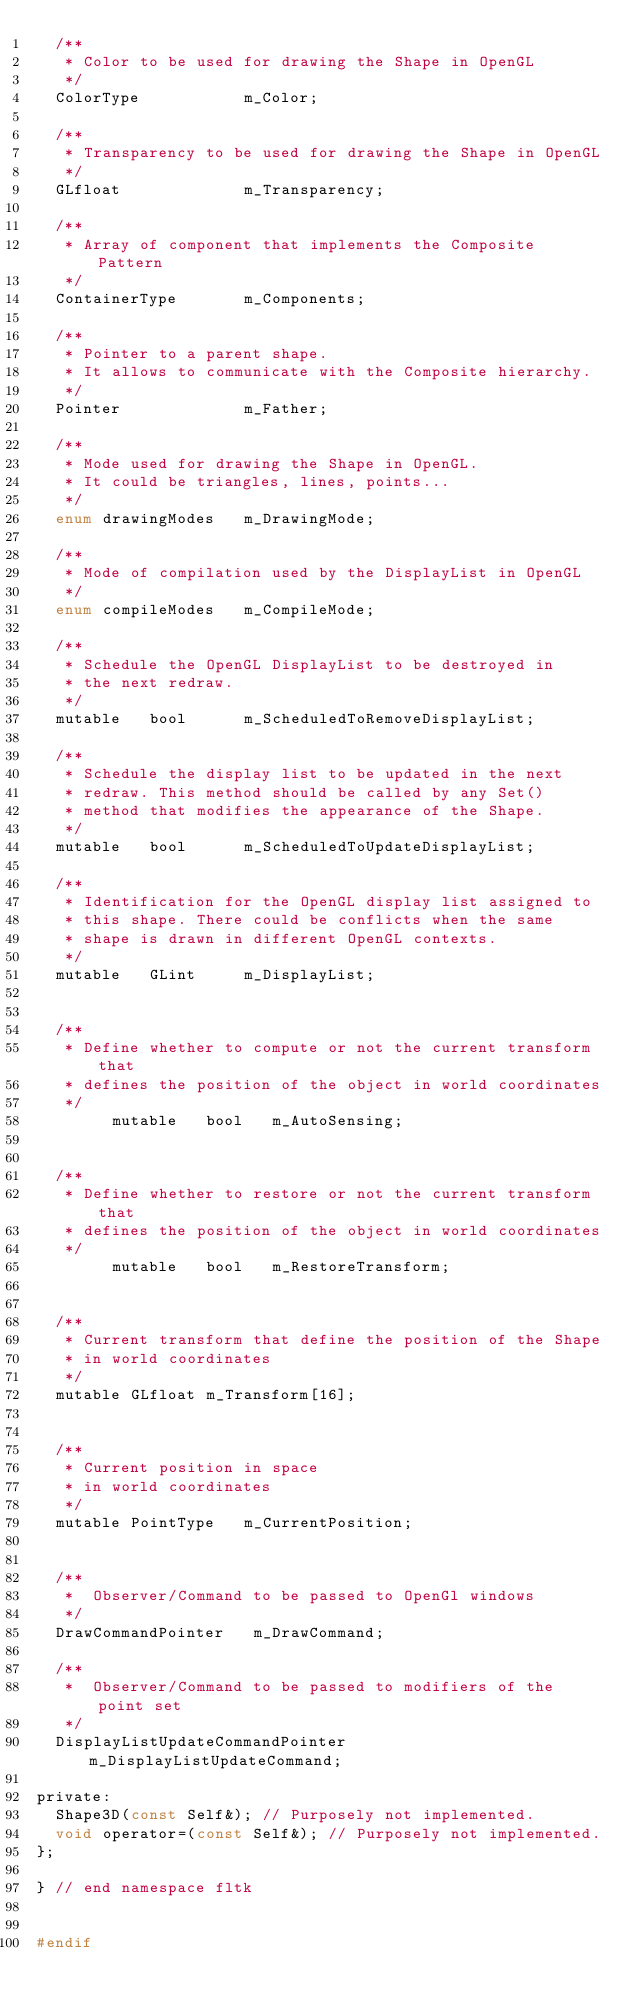<code> <loc_0><loc_0><loc_500><loc_500><_C_>  /**
   * Color to be used for drawing the Shape in OpenGL
   */
  ColorType           m_Color;

  /**
   * Transparency to be used for drawing the Shape in OpenGL
   */
  GLfloat             m_Transparency;

  /**
   * Array of component that implements the Composite Pattern
   */
  ContainerType       m_Components;

  /**
   * Pointer to a parent shape.
   * It allows to communicate with the Composite hierarchy.
   */
  Pointer             m_Father;

  /**
   * Mode used for drawing the Shape in OpenGL.
   * It could be triangles, lines, points...
   */
  enum drawingModes   m_DrawingMode;

  /**
   * Mode of compilation used by the DisplayList in OpenGL
   */
  enum compileModes   m_CompileMode;

  /**
   * Schedule the OpenGL DisplayList to be destroyed in 
   * the next redraw.
   */
  mutable   bool      m_ScheduledToRemoveDisplayList;

  /**
   * Schedule the display list to be updated in the next
   * redraw. This method should be called by any Set() 
   * method that modifies the appearance of the Shape.
   */
  mutable   bool      m_ScheduledToUpdateDisplayList;

  /**
   * Identification for the OpenGL display list assigned to
   * this shape. There could be conflicts when the same
   * shape is drawn in different OpenGL contexts.
   */
  mutable   GLint     m_DisplayList;


  /**
   * Define whether to compute or not the current transform that
   * defines the position of the object in world coordinates
   */
        mutable   bool   m_AutoSensing; 


  /**
   * Define whether to restore or not the current transform that
   * defines the position of the object in world coordinates
   */
        mutable   bool   m_RestoreTransform; 


  /**
   * Current transform that define the position of the Shape
   * in world coordinates
   */
  mutable GLfloat m_Transform[16];


  /**
   * Current position in space
   * in world coordinates
   */
  mutable PointType   m_CurrentPosition;


  /** 
   *  Observer/Command to be passed to OpenGl windows
   */ 
  DrawCommandPointer   m_DrawCommand;

  /** 
   *  Observer/Command to be passed to modifiers of the point set
   */ 
  DisplayListUpdateCommandPointer   m_DisplayListUpdateCommand;

private:
  Shape3D(const Self&); // Purposely not implemented.
  void operator=(const Self&); // Purposely not implemented.
};

} // end namespace fltk


#endif
</code> 